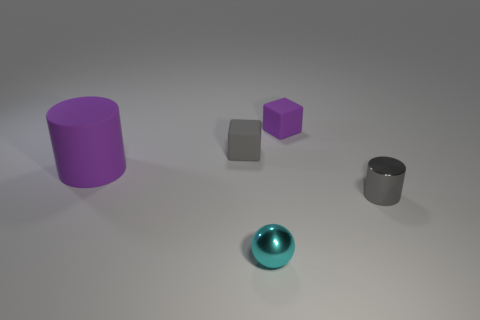Is there any other thing that is the same size as the matte cylinder?
Make the answer very short. No. Is the color of the tiny rubber cube on the left side of the tiny purple object the same as the tiny cylinder?
Provide a short and direct response. Yes. How many shiny objects are either gray cubes or gray balls?
Provide a succinct answer. 0. What is the shape of the cyan thing?
Keep it short and to the point. Sphere. Is there any other thing that is the same material as the tiny gray cube?
Make the answer very short. Yes. Are the ball and the tiny purple cube made of the same material?
Make the answer very short. No. There is a thing to the right of the small rubber block on the right side of the cyan sphere; is there a cyan sphere that is behind it?
Give a very brief answer. No. How many other things are there of the same shape as the tiny cyan thing?
Your answer should be compact. 0. What shape is the thing that is both right of the rubber cylinder and on the left side of the ball?
Make the answer very short. Cube. What color is the tiny object that is behind the gray thing to the left of the tiny gray cylinder that is to the right of the small cyan metal sphere?
Provide a short and direct response. Purple. 